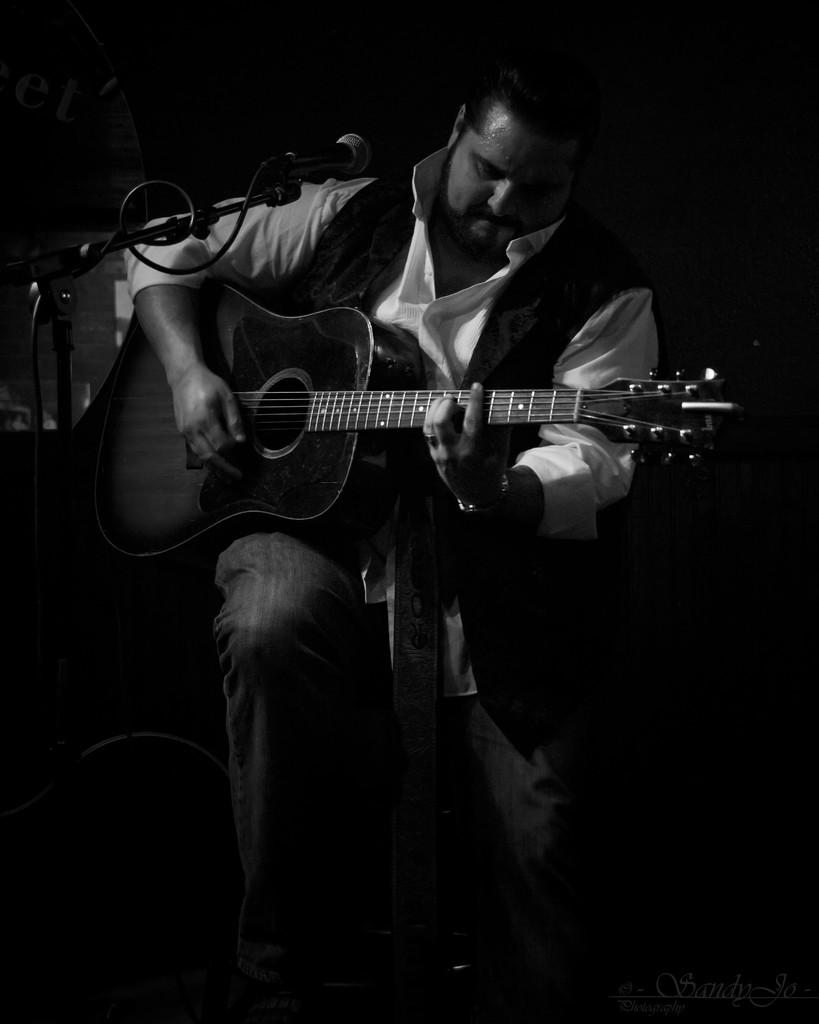What is the main subject of the image? There is a person in the image. What is the person holding in his hand? The person is holding a guitar in his hand. What is the color scheme of the image? The image is black and white. What type of vegetable is being sorted in the image? There is no vegetable or sorting activity present in the image. What is the crack in the image? There is no crack visible in the image. 